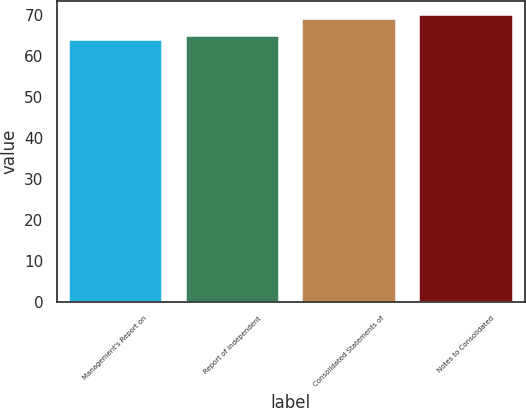<chart> <loc_0><loc_0><loc_500><loc_500><bar_chart><fcel>Management's Report on<fcel>Report of Independent<fcel>Consolidated Statements of<fcel>Notes to Consolidated<nl><fcel>64<fcel>65<fcel>69<fcel>70<nl></chart> 